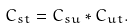Convert formula to latex. <formula><loc_0><loc_0><loc_500><loc_500>C _ { s t } = C _ { s u } * C _ { u t } .</formula> 